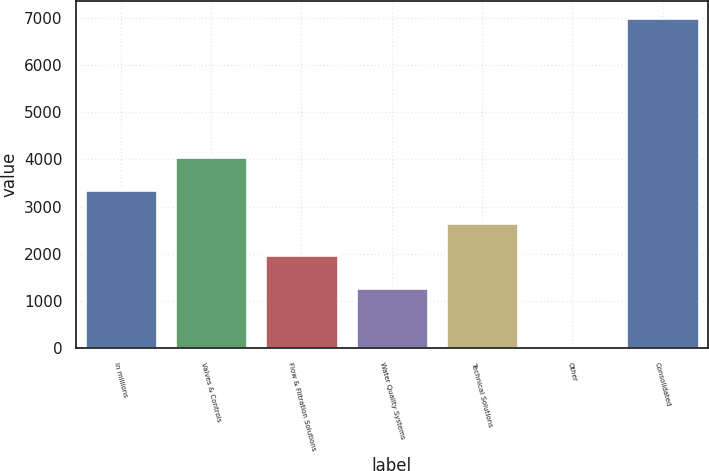Convert chart to OTSL. <chart><loc_0><loc_0><loc_500><loc_500><bar_chart><fcel>In millions<fcel>Valves & Controls<fcel>Flow & Filtration Solutions<fcel>Water Quality Systems<fcel>Technical Solutions<fcel>Other<fcel>Consolidated<nl><fcel>3358.26<fcel>4054.58<fcel>1965.62<fcel>1269.3<fcel>2661.94<fcel>36.5<fcel>6999.7<nl></chart> 